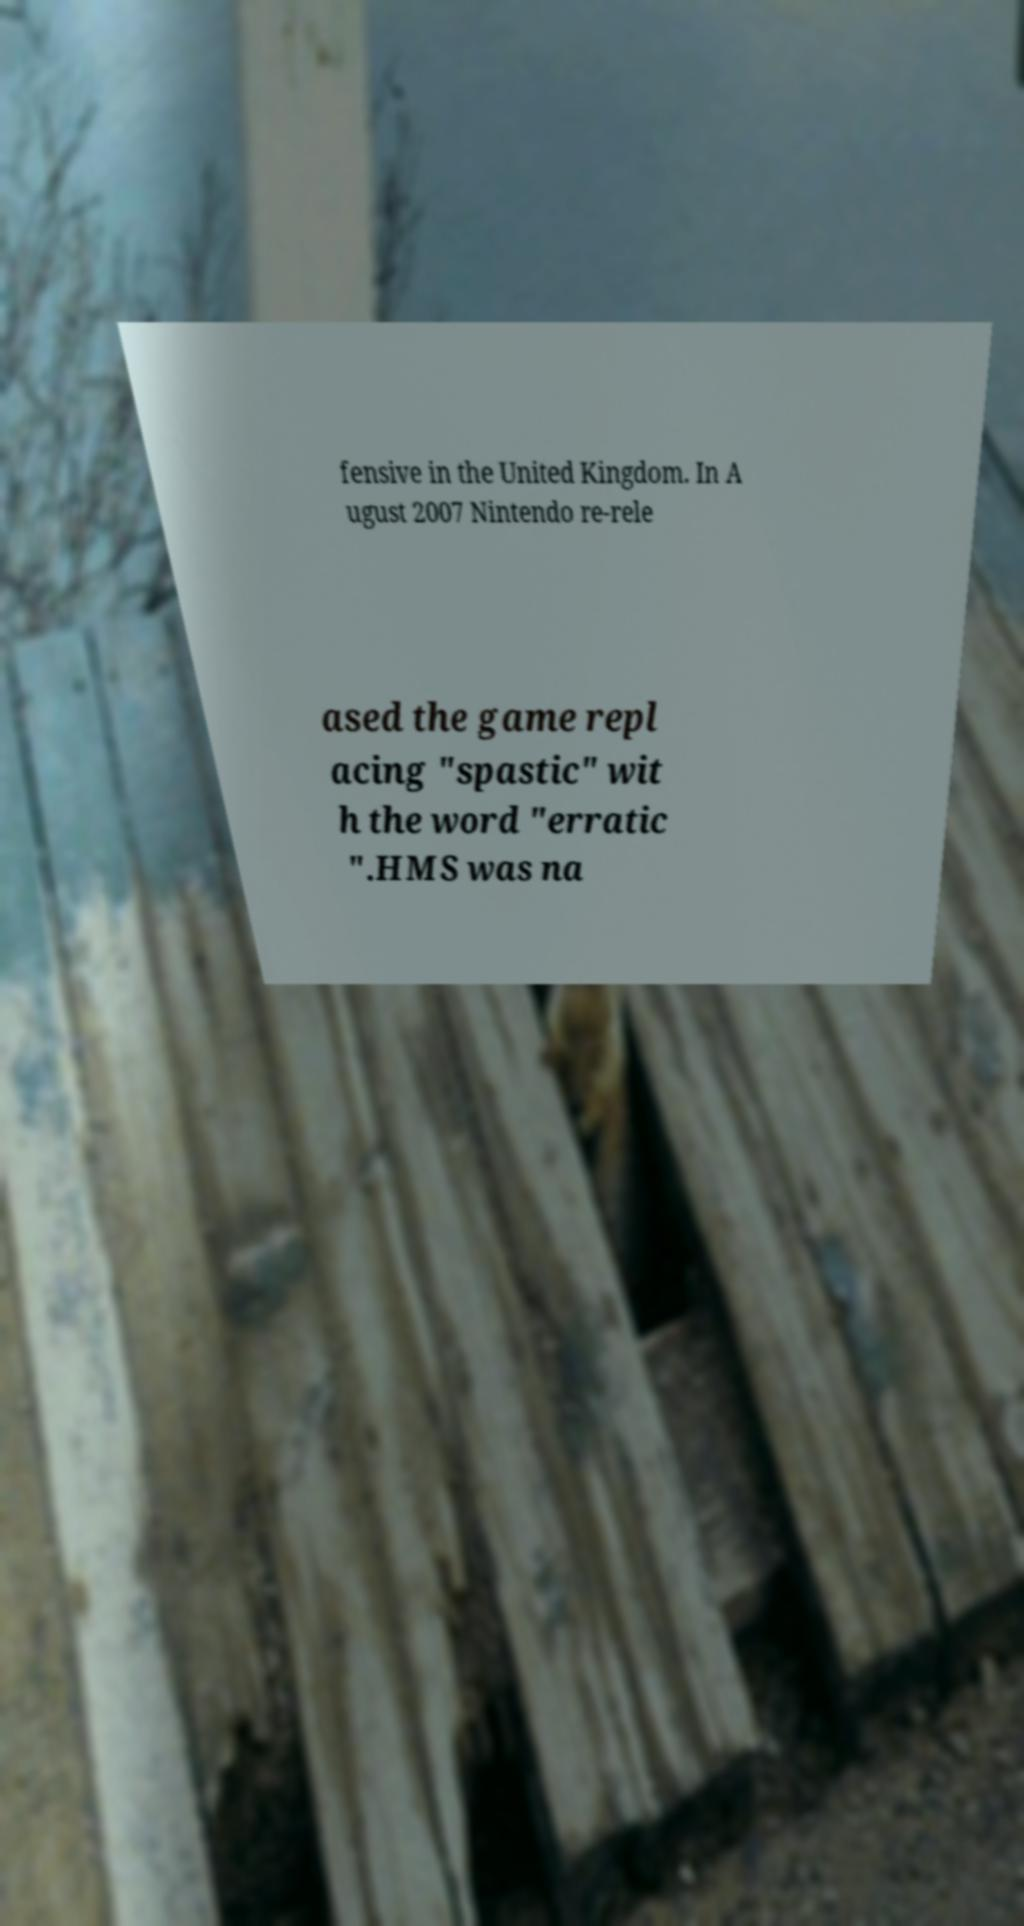Please identify and transcribe the text found in this image. fensive in the United Kingdom. In A ugust 2007 Nintendo re-rele ased the game repl acing "spastic" wit h the word "erratic ".HMS was na 